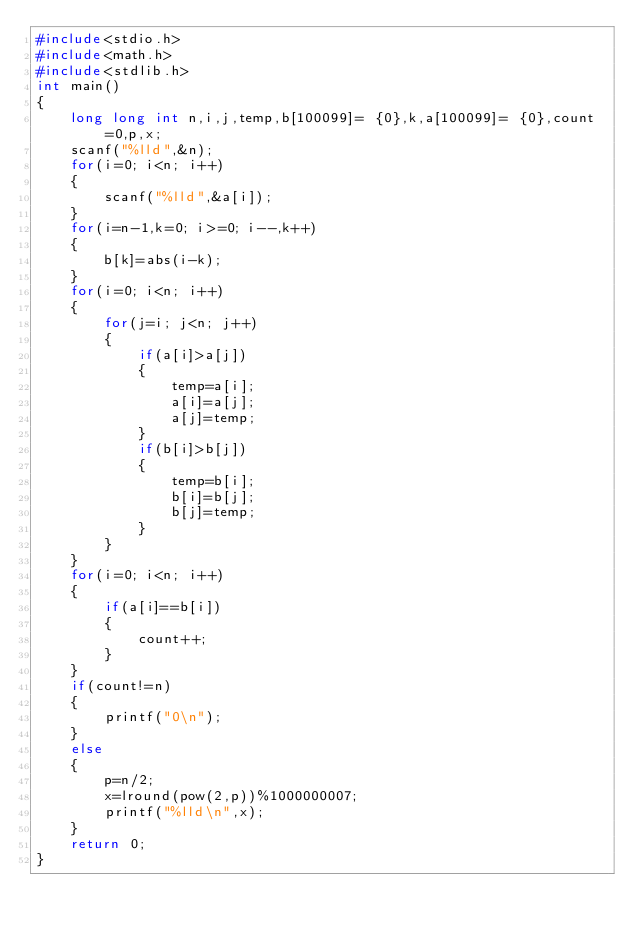<code> <loc_0><loc_0><loc_500><loc_500><_C++_>#include<stdio.h>
#include<math.h>
#include<stdlib.h>
int main()
{
    long long int n,i,j,temp,b[100099]= {0},k,a[100099]= {0},count=0,p,x;
    scanf("%lld",&n);
    for(i=0; i<n; i++)
    {
        scanf("%lld",&a[i]);
    }
    for(i=n-1,k=0; i>=0; i--,k++)
    {
        b[k]=abs(i-k);
    }
    for(i=0; i<n; i++)
    {
        for(j=i; j<n; j++)
        {
            if(a[i]>a[j])
            {
                temp=a[i];
                a[i]=a[j];
                a[j]=temp;
            }
            if(b[i]>b[j])
            {
                temp=b[i];
                b[i]=b[j];
                b[j]=temp;
            }
        }
    }
    for(i=0; i<n; i++)
    {
        if(a[i]==b[i])
        {
            count++;
        }
    }
    if(count!=n)
    {
        printf("0\n");
    }
    else
    {
        p=n/2;
        x=lround(pow(2,p))%1000000007;
        printf("%lld\n",x);
    }
    return 0;
}
</code> 